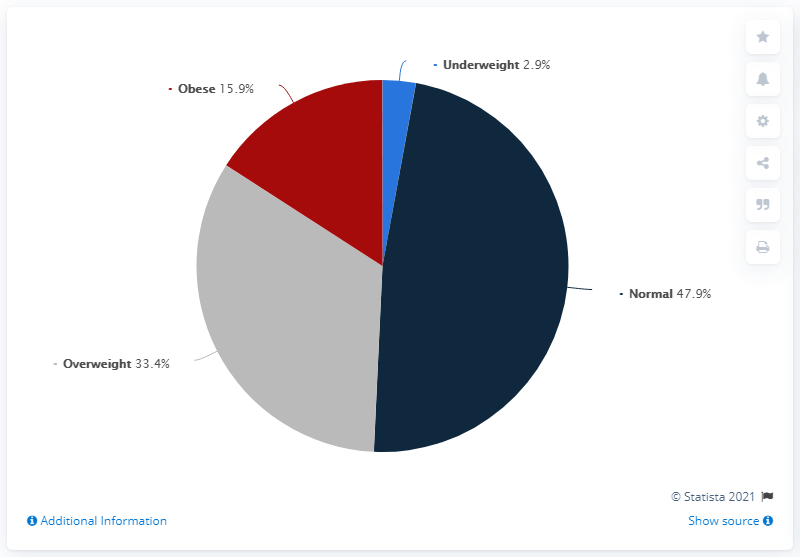Indicate a few pertinent items in this graphic. In 2018, it was found that 15.9% of the population in Belgium fell into one of the Body Mass Index (BMI) categories. The value of being overweight is greater than that of being obese or underweight. In the context of color representation, 'normal' is often associated with navy blue. 